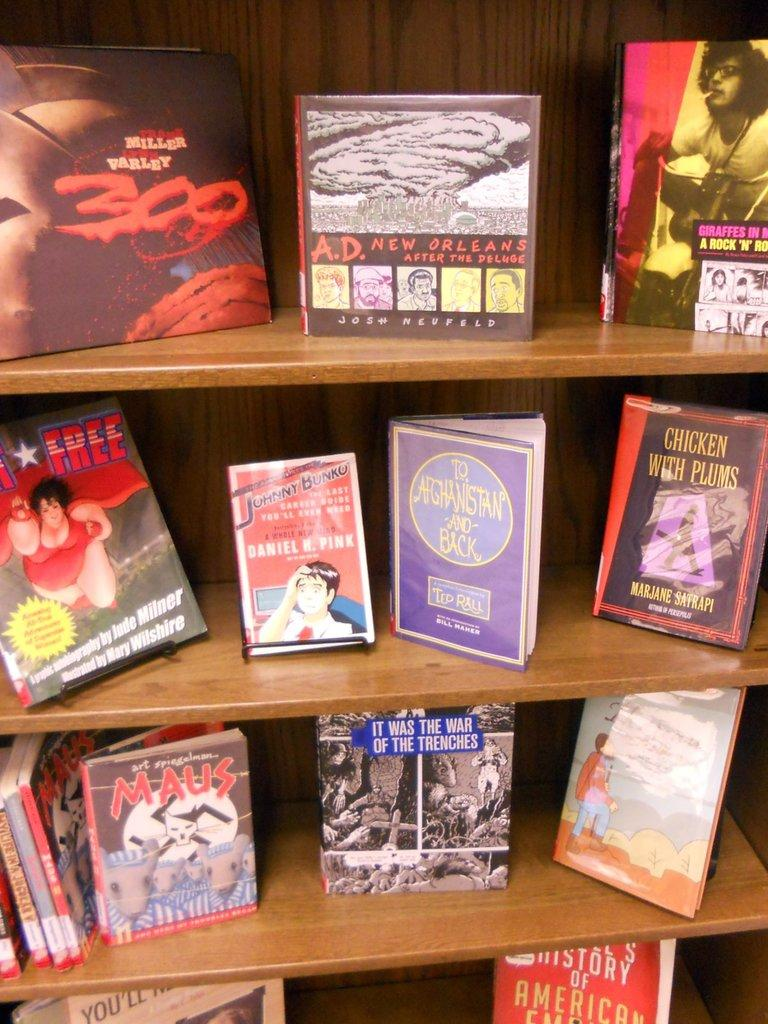<image>
Describe the image concisely. A book called chicken with plums sits on a library shelf. 